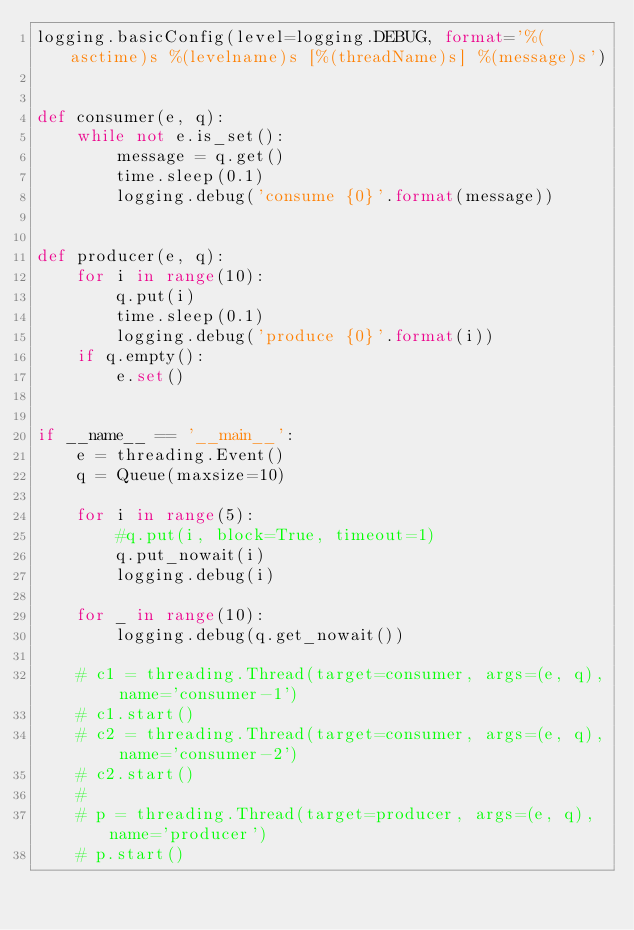Convert code to text. <code><loc_0><loc_0><loc_500><loc_500><_Python_>logging.basicConfig(level=logging.DEBUG, format='%(asctime)s %(levelname)s [%(threadName)s] %(message)s')


def consumer(e, q):
    while not e.is_set():
        message = q.get()
        time.sleep(0.1)
        logging.debug('consume {0}'.format(message))


def producer(e, q):
    for i in range(10):
        q.put(i)
        time.sleep(0.1)
        logging.debug('produce {0}'.format(i))
    if q.empty():
        e.set()


if __name__ == '__main__':
    e = threading.Event()
    q = Queue(maxsize=10)

    for i in range(5):
        #q.put(i, block=True, timeout=1)
        q.put_nowait(i)
        logging.debug(i)

    for _ in range(10):
        logging.debug(q.get_nowait())

    # c1 = threading.Thread(target=consumer, args=(e, q), name='consumer-1')
    # c1.start()
    # c2 = threading.Thread(target=consumer, args=(e, q), name='consumer-2')
    # c2.start()
    #
    # p = threading.Thread(target=producer, args=(e, q), name='producer')
    # p.start()</code> 